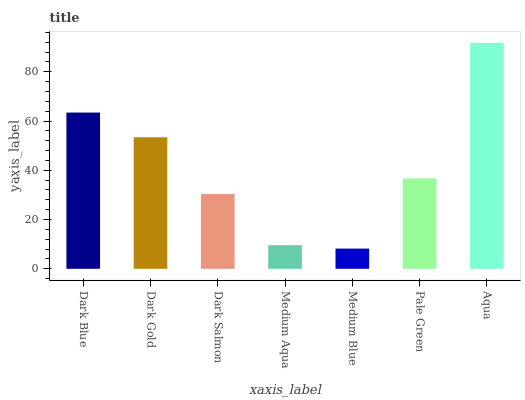Is Medium Blue the minimum?
Answer yes or no. Yes. Is Aqua the maximum?
Answer yes or no. Yes. Is Dark Gold the minimum?
Answer yes or no. No. Is Dark Gold the maximum?
Answer yes or no. No. Is Dark Blue greater than Dark Gold?
Answer yes or no. Yes. Is Dark Gold less than Dark Blue?
Answer yes or no. Yes. Is Dark Gold greater than Dark Blue?
Answer yes or no. No. Is Dark Blue less than Dark Gold?
Answer yes or no. No. Is Pale Green the high median?
Answer yes or no. Yes. Is Pale Green the low median?
Answer yes or no. Yes. Is Medium Aqua the high median?
Answer yes or no. No. Is Medium Blue the low median?
Answer yes or no. No. 